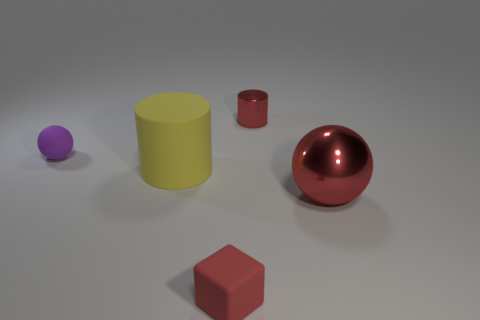Subtract all purple spheres. Subtract all gray cylinders. How many spheres are left? 1 Add 1 large brown objects. How many objects exist? 6 Subtract all cylinders. How many objects are left? 3 Add 1 tiny cubes. How many tiny cubes exist? 2 Subtract 0 blue balls. How many objects are left? 5 Subtract all large metal cylinders. Subtract all small red shiny objects. How many objects are left? 4 Add 1 matte cylinders. How many matte cylinders are left? 2 